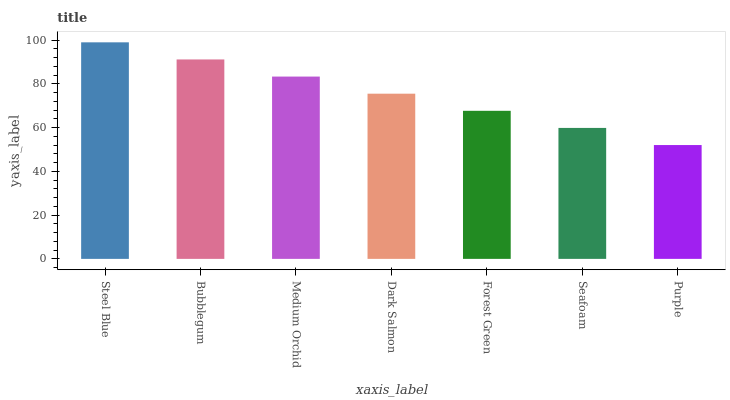Is Purple the minimum?
Answer yes or no. Yes. Is Steel Blue the maximum?
Answer yes or no. Yes. Is Bubblegum the minimum?
Answer yes or no. No. Is Bubblegum the maximum?
Answer yes or no. No. Is Steel Blue greater than Bubblegum?
Answer yes or no. Yes. Is Bubblegum less than Steel Blue?
Answer yes or no. Yes. Is Bubblegum greater than Steel Blue?
Answer yes or no. No. Is Steel Blue less than Bubblegum?
Answer yes or no. No. Is Dark Salmon the high median?
Answer yes or no. Yes. Is Dark Salmon the low median?
Answer yes or no. Yes. Is Steel Blue the high median?
Answer yes or no. No. Is Seafoam the low median?
Answer yes or no. No. 